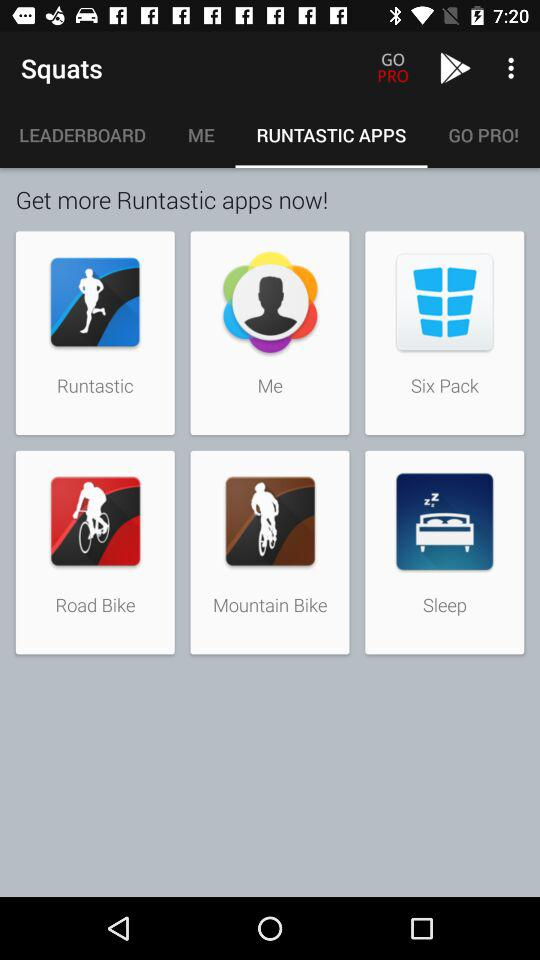What is the application name? The application names are "Squats", "Google Play Store", "Runtastic", "Me", "Six Pack", "Road Bike", "Mountain Bike" and "Sleep". 